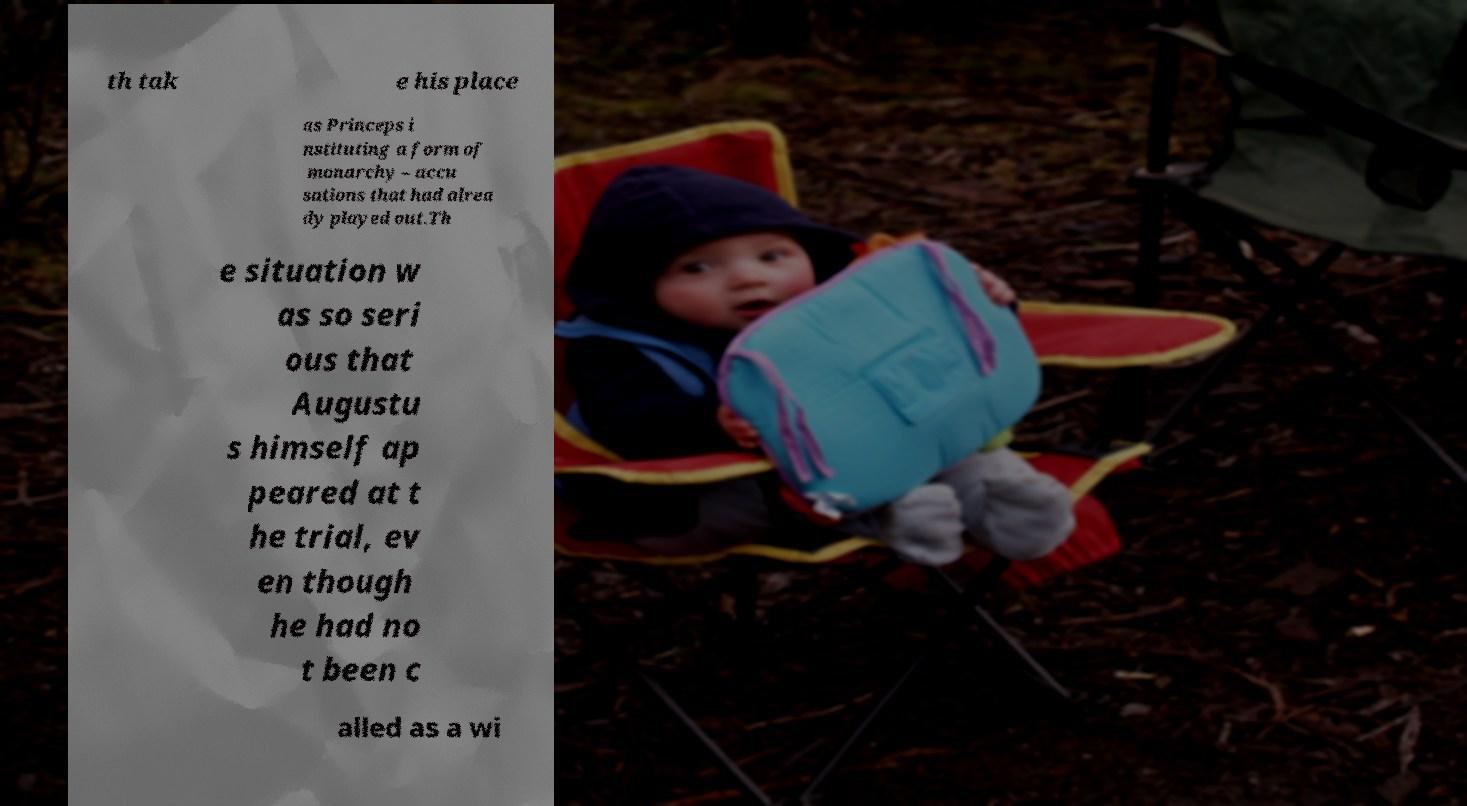Could you extract and type out the text from this image? th tak e his place as Princeps i nstituting a form of monarchy – accu sations that had alrea dy played out.Th e situation w as so seri ous that Augustu s himself ap peared at t he trial, ev en though he had no t been c alled as a wi 